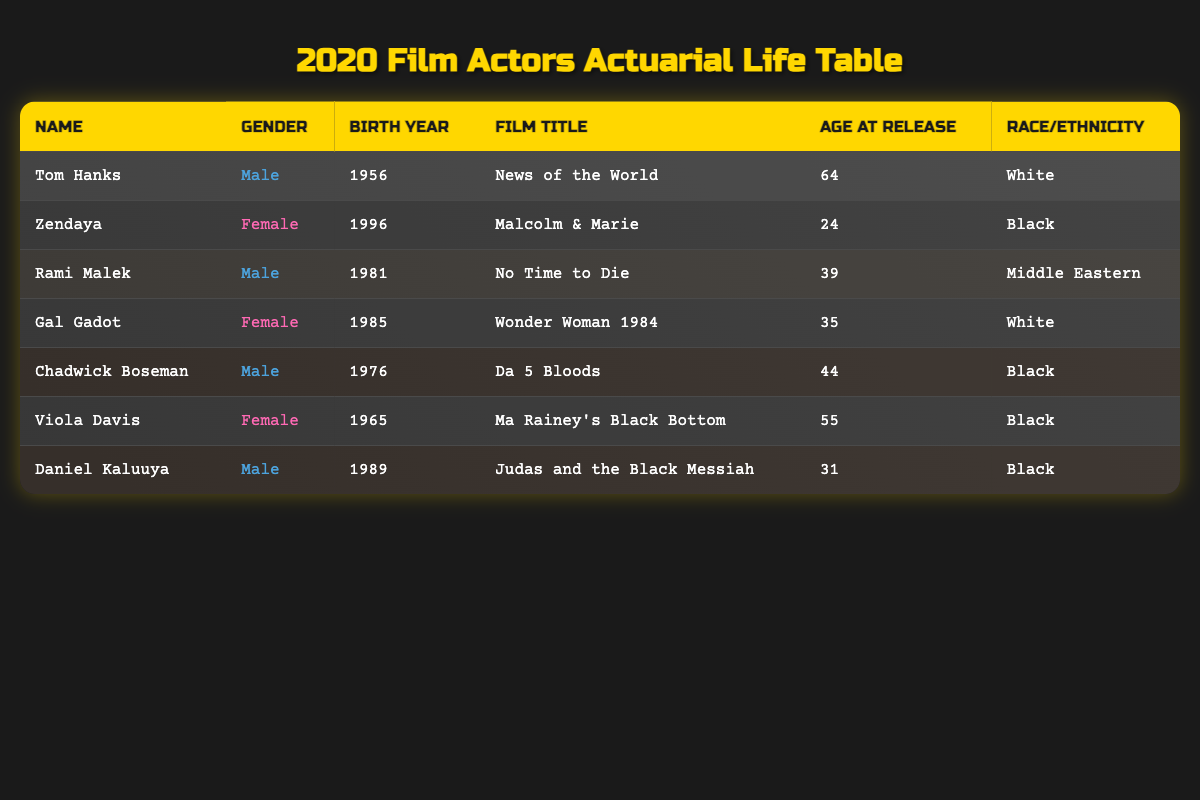What is the age of Tom Hanks at the time of his film release? Tom Hanks is listed in the table with an age of 64 at the time of the release of "News of the World."
Answer: 64 How many actors are female in this table? The table lists 3 female actors: Zendaya, Gal Gadot, and Viola Davis.
Answer: 3 What is the average age of the actors presented in the table? The ages of the actors are 64, 24, 39, 35, 44, 55, and 31. Summing these gives 64 + 24 + 39 + 35 + 44 + 55 + 31 = 292. There are 7 actors, so the average age is 292 / 7 = 41.71.
Answer: 41.71 Is Daniel Kaluuya older than Rami Malek? Daniel Kaluuya is born in 1989 and is 31 years old, while Rami Malek is born in 1981 and is 39 years old. Since 31 is less than 39, Daniel Kaluuya is not older than Rami Malek.
Answer: No What percentage of the actors in this table are White? There are 7 actors total, with 3 identified as White (Tom Hanks and Gal Gadot). To find the percentage, we calculate (3/7) * 100 = 42.86% (approximately).
Answer: 42.86% What is the oldest actor in the table, and how old are they? Tom Hanks is listed as the oldest actor in the table at 64 years old, compared to all other ages provided.
Answer: Tom Hanks, 64 How many movies feature Black actors according to the table? The table shows that there are 4 movies featuring Black actors: "Malcolm & Marie," "Da 5 Bloods," "Ma Rainey's Black Bottom," and "Judas and the Black Messiah."
Answer: 4 What is the racial demographic distribution of the highlighted actors in the table? The table lists 3 White actors, 4 Black actors, and 1 Middle Eastern actor. Therefore, the distribution is 3 out of 7 are White (approximately 42.86%), 4 out of 7 are Black (approximately 57.14%), and 1 out of 7 is Middle Eastern (approximately 14.29%).
Answer: 3 White, 4 Black, 1 Middle Eastern 